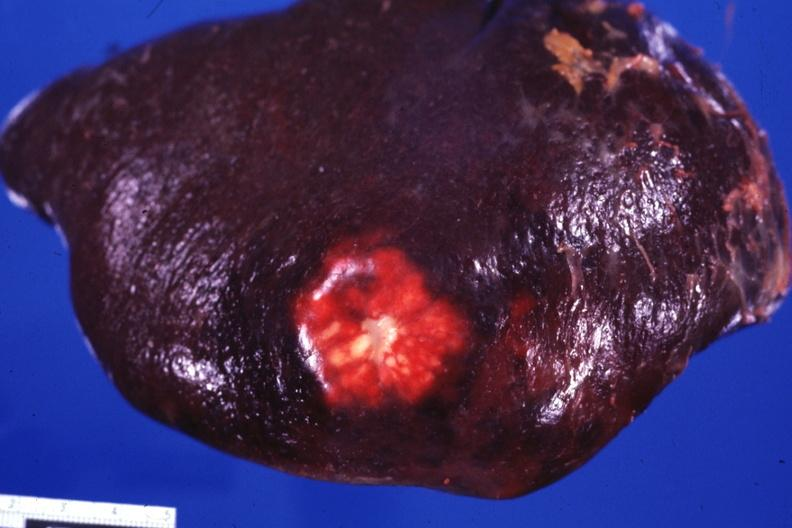s metastatic carcinoma colon present?
Answer the question using a single word or phrase. Yes 